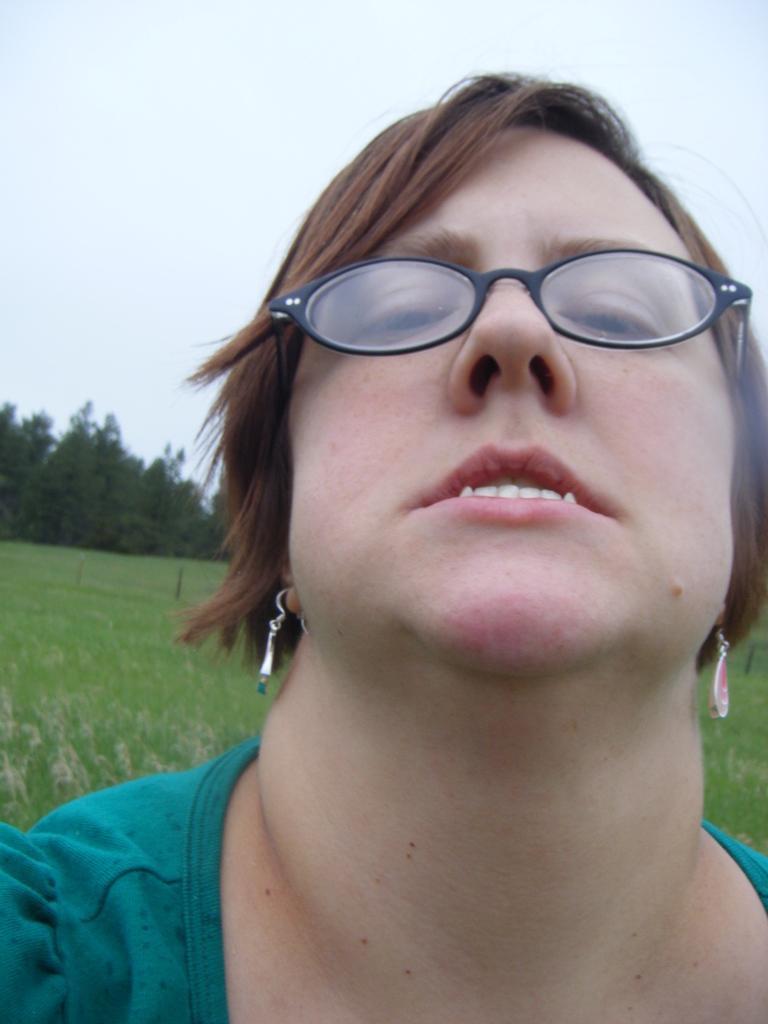Please provide a concise description of this image. In the foreground of the image we can see a woman wearing spectacles, dress and earrings. In the background, we can see the grass, trees and the sky. 